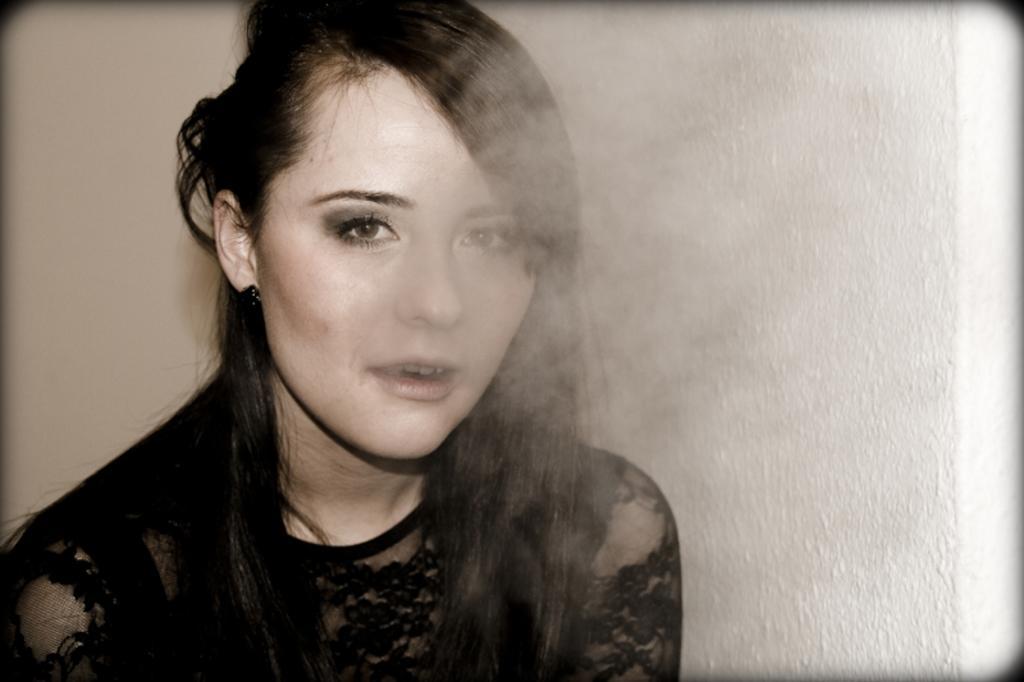In one or two sentences, can you explain what this image depicts? On the left side, there is a woman in a black color dress, releasing smoke from her mouth. In the background, there is a white wall. 